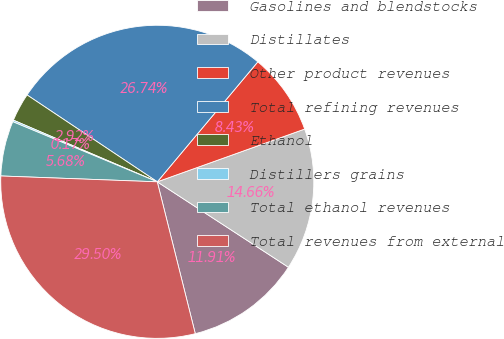Convert chart. <chart><loc_0><loc_0><loc_500><loc_500><pie_chart><fcel>Gasolines and blendstocks<fcel>Distillates<fcel>Other product revenues<fcel>Total refining revenues<fcel>Ethanol<fcel>Distillers grains<fcel>Total ethanol revenues<fcel>Total revenues from external<nl><fcel>11.91%<fcel>14.66%<fcel>8.43%<fcel>26.74%<fcel>2.92%<fcel>0.17%<fcel>5.68%<fcel>29.5%<nl></chart> 